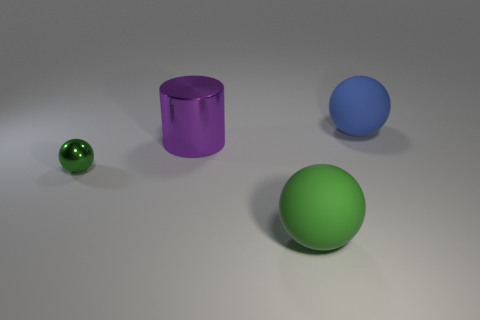Does the purple cylinder have the same material as the big object that is in front of the purple metallic thing?
Your answer should be very brief. No. There is a purple thing that is the same material as the small green ball; what is its size?
Ensure brevity in your answer.  Large. Is there a cyan rubber thing of the same shape as the tiny green object?
Give a very brief answer. No. What number of objects are either rubber objects that are in front of the blue thing or balls?
Make the answer very short. 3. There is another thing that is the same color as the tiny thing; what is its size?
Give a very brief answer. Large. There is a big thing behind the big purple metal cylinder; is it the same color as the big rubber object that is in front of the small green sphere?
Your response must be concise. No. How big is the blue thing?
Your answer should be compact. Large. How many small objects are blue things or red things?
Offer a very short reply. 0. What color is the ball that is the same size as the green rubber thing?
Keep it short and to the point. Blue. What number of other objects are the same shape as the big green object?
Ensure brevity in your answer.  2. 